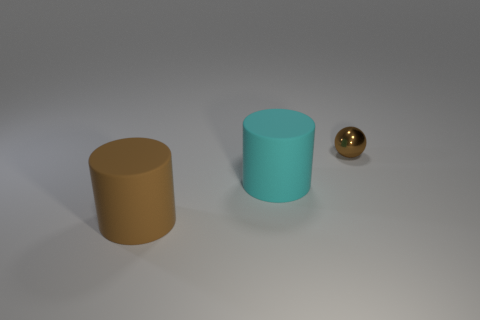Is there any other thing that is the same size as the brown ball?
Ensure brevity in your answer.  No. Is there anything else that is the same material as the tiny thing?
Give a very brief answer. No. There is a object that is the same color as the ball; what is its size?
Provide a short and direct response. Large. What number of big objects are in front of the cylinder right of the brown thing that is on the left side of the large cyan thing?
Offer a terse response. 1. Does the rubber object in front of the cyan matte object have the same shape as the rubber thing that is on the right side of the brown rubber cylinder?
Give a very brief answer. Yes. What number of things are either small brown shiny objects or cyan rubber cylinders?
Your answer should be very brief. 2. What material is the small ball that is right of the brown thing that is in front of the tiny sphere?
Offer a very short reply. Metal. Is there a rubber object of the same color as the small metal ball?
Offer a very short reply. Yes. There is another thing that is the same size as the cyan rubber object; what color is it?
Provide a succinct answer. Brown. What is the big cylinder that is in front of the rubber thing behind the big object in front of the big cyan rubber thing made of?
Your response must be concise. Rubber. 